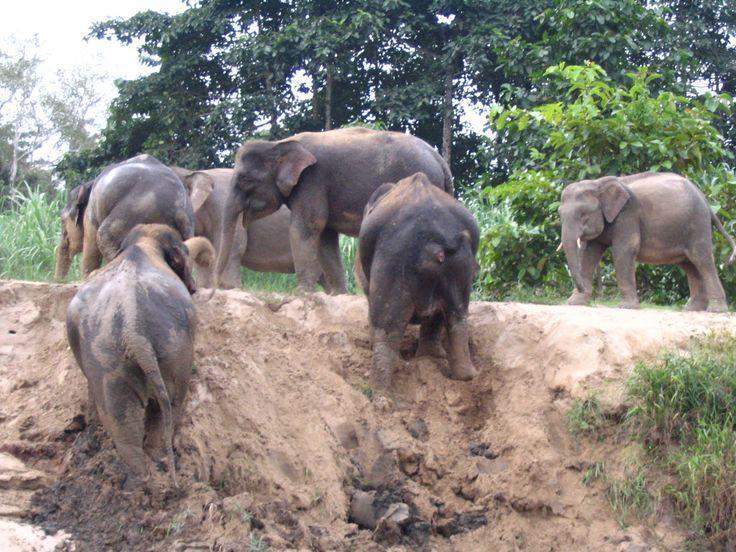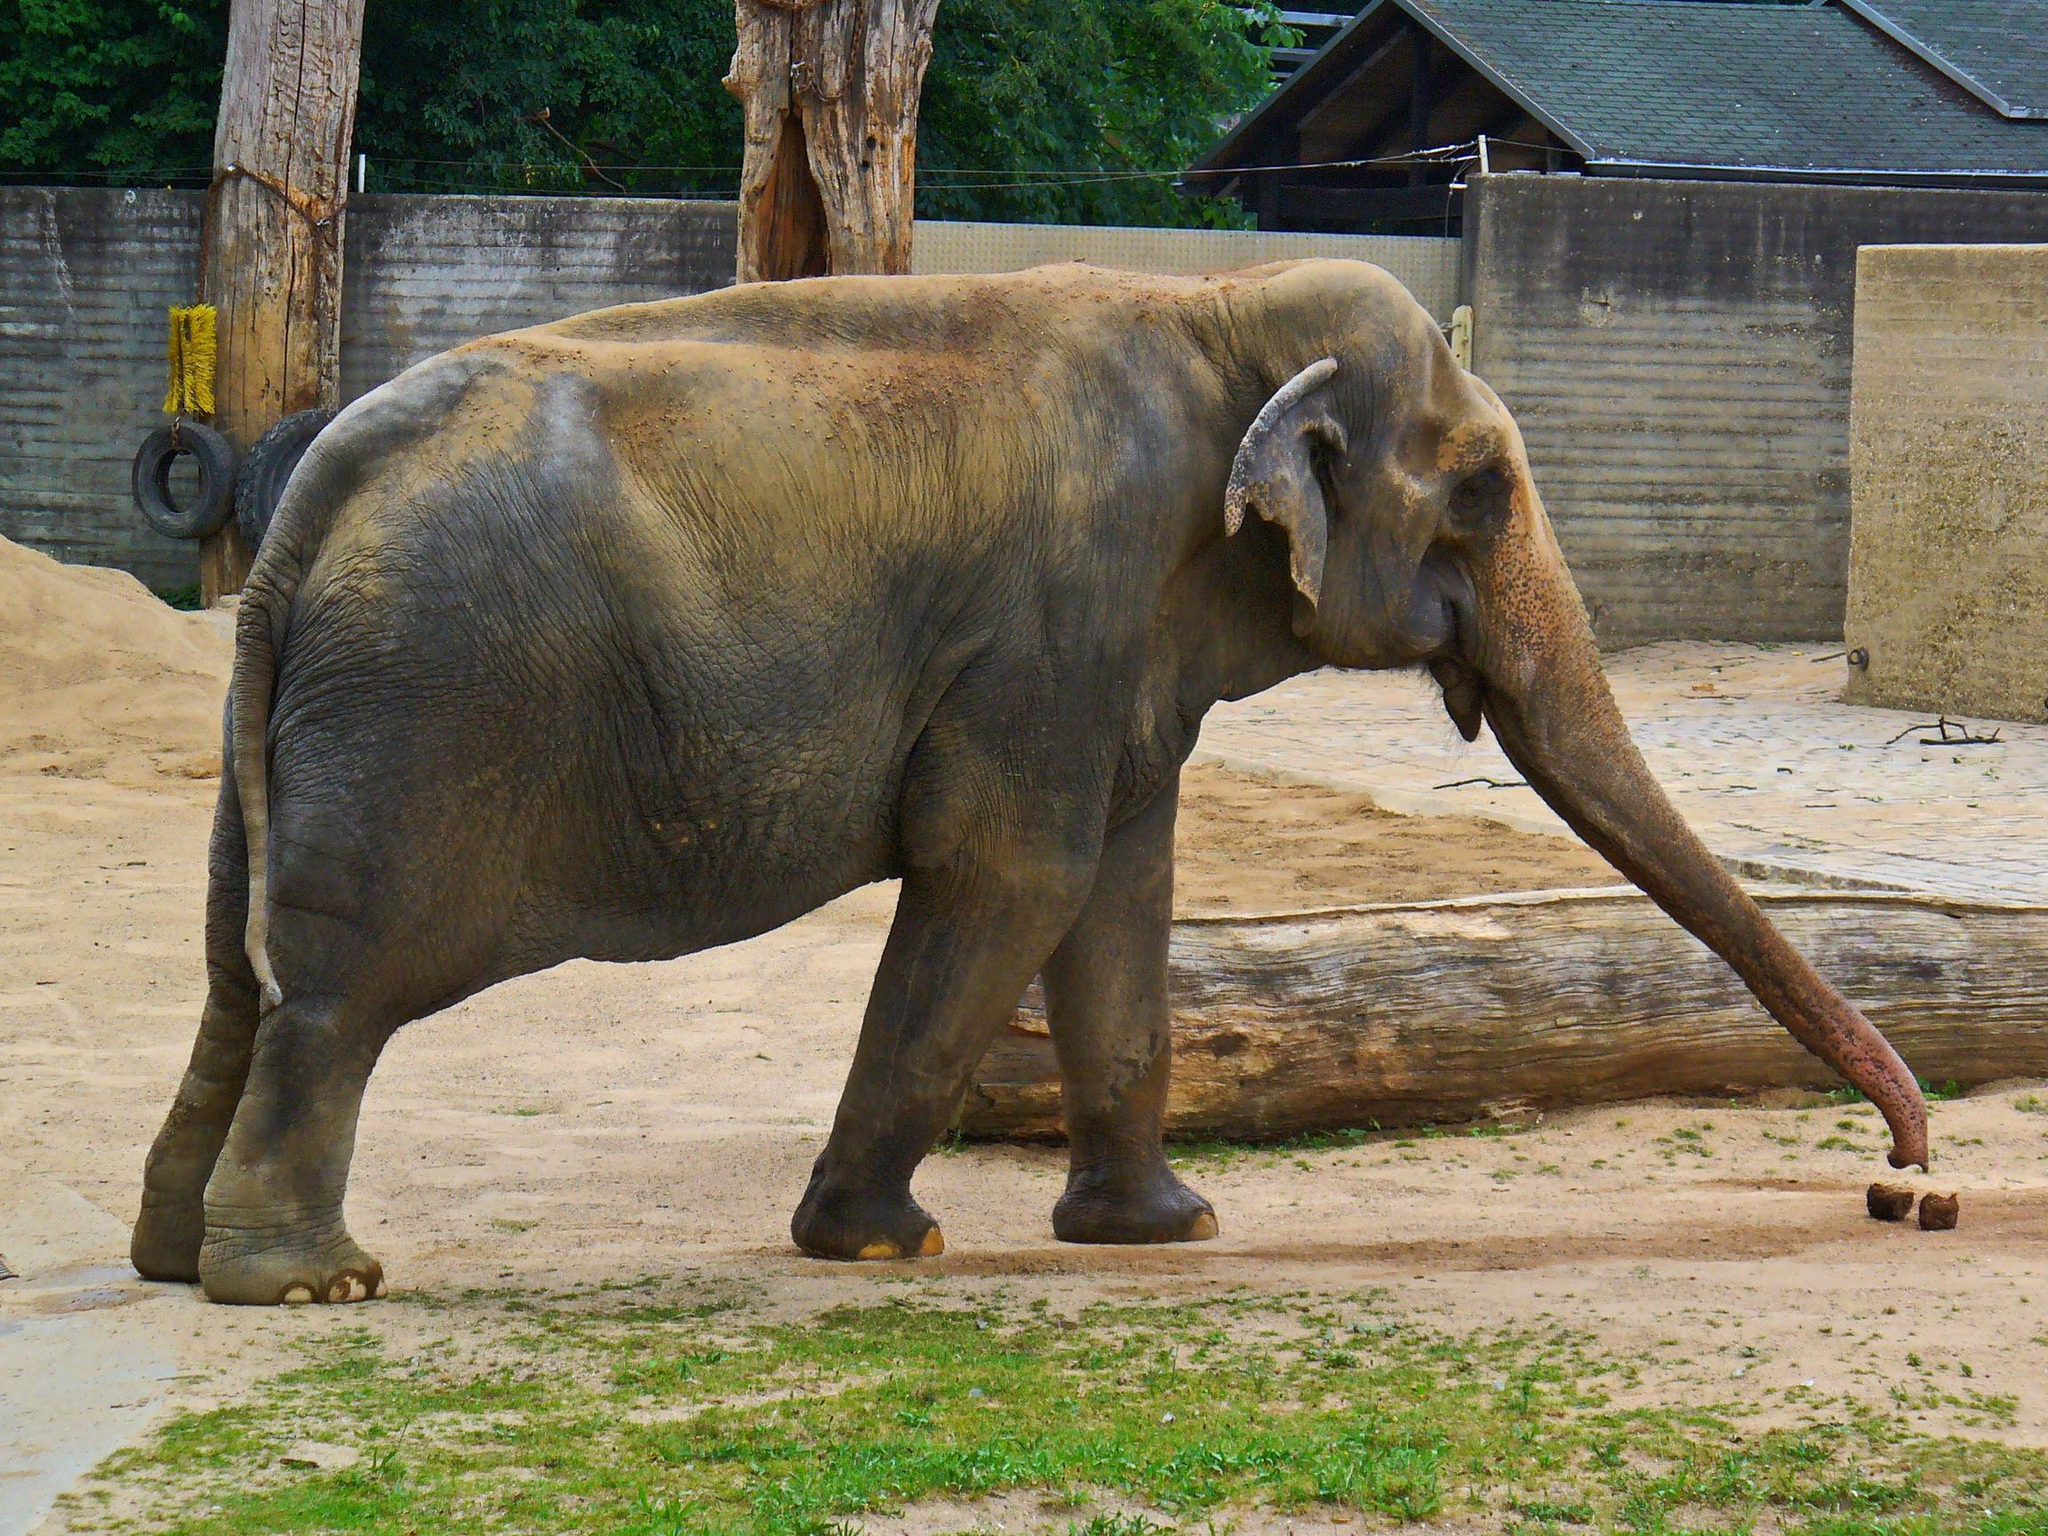The first image is the image on the left, the second image is the image on the right. Evaluate the accuracy of this statement regarding the images: "The elephant in the right image is facing towards the right.". Is it true? Answer yes or no. Yes. The first image is the image on the left, the second image is the image on the right. Given the left and right images, does the statement "An image shows one elephant standing on a surface surrounded by a curved raised edge." hold true? Answer yes or no. No. 